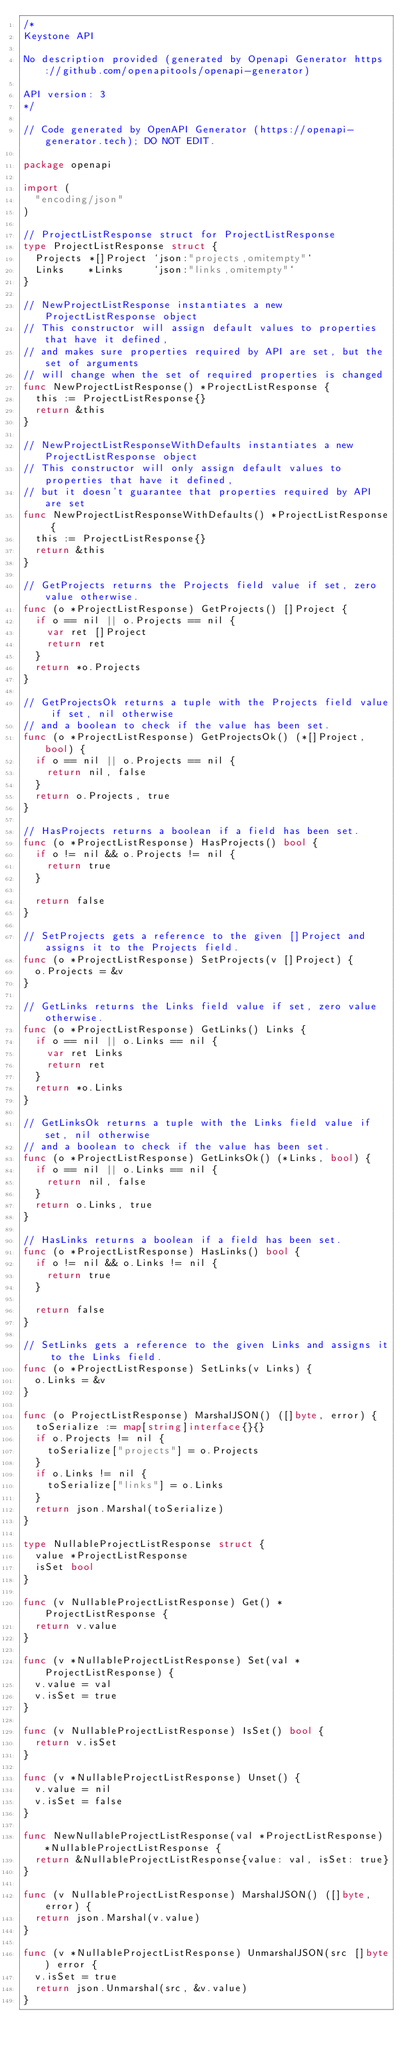<code> <loc_0><loc_0><loc_500><loc_500><_Go_>/*
Keystone API

No description provided (generated by Openapi Generator https://github.com/openapitools/openapi-generator)

API version: 3
*/

// Code generated by OpenAPI Generator (https://openapi-generator.tech); DO NOT EDIT.

package openapi

import (
	"encoding/json"
)

// ProjectListResponse struct for ProjectListResponse
type ProjectListResponse struct {
	Projects *[]Project `json:"projects,omitempty"`
	Links    *Links     `json:"links,omitempty"`
}

// NewProjectListResponse instantiates a new ProjectListResponse object
// This constructor will assign default values to properties that have it defined,
// and makes sure properties required by API are set, but the set of arguments
// will change when the set of required properties is changed
func NewProjectListResponse() *ProjectListResponse {
	this := ProjectListResponse{}
	return &this
}

// NewProjectListResponseWithDefaults instantiates a new ProjectListResponse object
// This constructor will only assign default values to properties that have it defined,
// but it doesn't guarantee that properties required by API are set
func NewProjectListResponseWithDefaults() *ProjectListResponse {
	this := ProjectListResponse{}
	return &this
}

// GetProjects returns the Projects field value if set, zero value otherwise.
func (o *ProjectListResponse) GetProjects() []Project {
	if o == nil || o.Projects == nil {
		var ret []Project
		return ret
	}
	return *o.Projects
}

// GetProjectsOk returns a tuple with the Projects field value if set, nil otherwise
// and a boolean to check if the value has been set.
func (o *ProjectListResponse) GetProjectsOk() (*[]Project, bool) {
	if o == nil || o.Projects == nil {
		return nil, false
	}
	return o.Projects, true
}

// HasProjects returns a boolean if a field has been set.
func (o *ProjectListResponse) HasProjects() bool {
	if o != nil && o.Projects != nil {
		return true
	}

	return false
}

// SetProjects gets a reference to the given []Project and assigns it to the Projects field.
func (o *ProjectListResponse) SetProjects(v []Project) {
	o.Projects = &v
}

// GetLinks returns the Links field value if set, zero value otherwise.
func (o *ProjectListResponse) GetLinks() Links {
	if o == nil || o.Links == nil {
		var ret Links
		return ret
	}
	return *o.Links
}

// GetLinksOk returns a tuple with the Links field value if set, nil otherwise
// and a boolean to check if the value has been set.
func (o *ProjectListResponse) GetLinksOk() (*Links, bool) {
	if o == nil || o.Links == nil {
		return nil, false
	}
	return o.Links, true
}

// HasLinks returns a boolean if a field has been set.
func (o *ProjectListResponse) HasLinks() bool {
	if o != nil && o.Links != nil {
		return true
	}

	return false
}

// SetLinks gets a reference to the given Links and assigns it to the Links field.
func (o *ProjectListResponse) SetLinks(v Links) {
	o.Links = &v
}

func (o ProjectListResponse) MarshalJSON() ([]byte, error) {
	toSerialize := map[string]interface{}{}
	if o.Projects != nil {
		toSerialize["projects"] = o.Projects
	}
	if o.Links != nil {
		toSerialize["links"] = o.Links
	}
	return json.Marshal(toSerialize)
}

type NullableProjectListResponse struct {
	value *ProjectListResponse
	isSet bool
}

func (v NullableProjectListResponse) Get() *ProjectListResponse {
	return v.value
}

func (v *NullableProjectListResponse) Set(val *ProjectListResponse) {
	v.value = val
	v.isSet = true
}

func (v NullableProjectListResponse) IsSet() bool {
	return v.isSet
}

func (v *NullableProjectListResponse) Unset() {
	v.value = nil
	v.isSet = false
}

func NewNullableProjectListResponse(val *ProjectListResponse) *NullableProjectListResponse {
	return &NullableProjectListResponse{value: val, isSet: true}
}

func (v NullableProjectListResponse) MarshalJSON() ([]byte, error) {
	return json.Marshal(v.value)
}

func (v *NullableProjectListResponse) UnmarshalJSON(src []byte) error {
	v.isSet = true
	return json.Unmarshal(src, &v.value)
}
</code> 